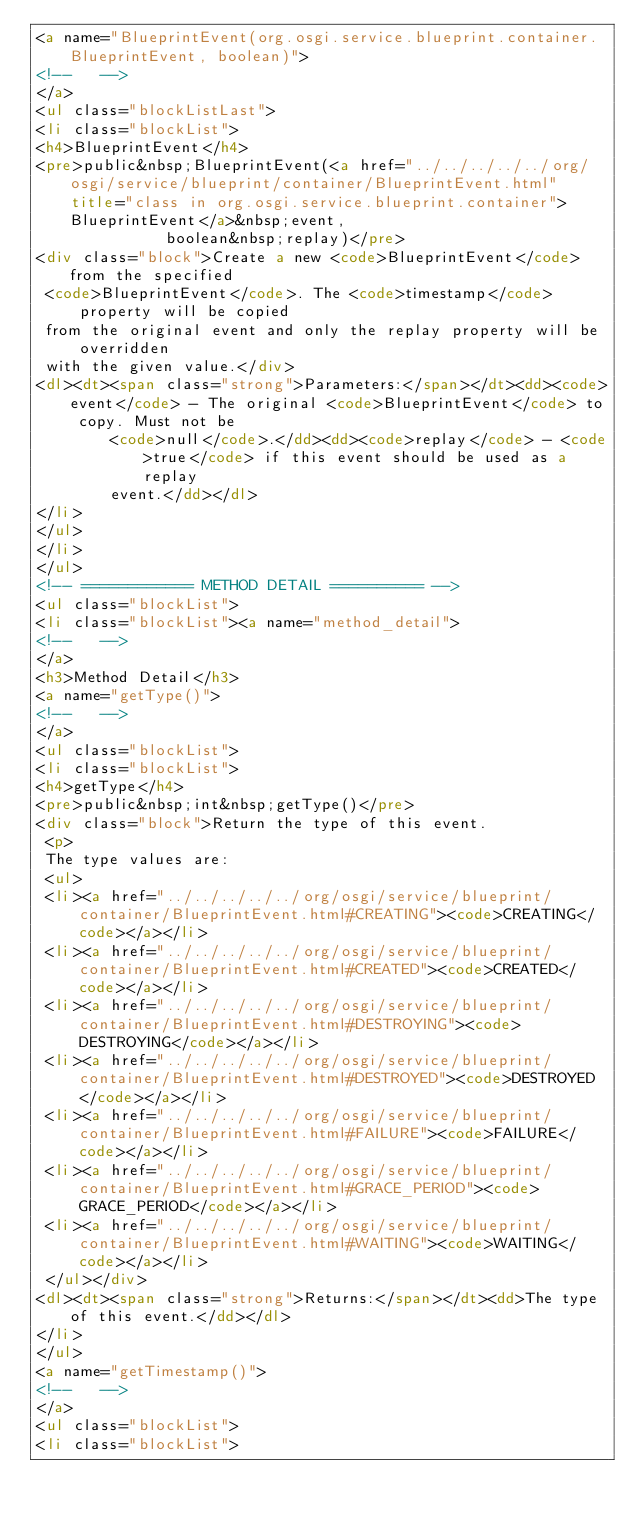<code> <loc_0><loc_0><loc_500><loc_500><_HTML_><a name="BlueprintEvent(org.osgi.service.blueprint.container.BlueprintEvent, boolean)">
<!--   -->
</a>
<ul class="blockListLast">
<li class="blockList">
<h4>BlueprintEvent</h4>
<pre>public&nbsp;BlueprintEvent(<a href="../../../../../org/osgi/service/blueprint/container/BlueprintEvent.html" title="class in org.osgi.service.blueprint.container">BlueprintEvent</a>&nbsp;event,
              boolean&nbsp;replay)</pre>
<div class="block">Create a new <code>BlueprintEvent</code> from the specified
 <code>BlueprintEvent</code>. The <code>timestamp</code> property will be copied
 from the original event and only the replay property will be overridden
 with the given value.</div>
<dl><dt><span class="strong">Parameters:</span></dt><dd><code>event</code> - The original <code>BlueprintEvent</code> to copy. Must not be
        <code>null</code>.</dd><dd><code>replay</code> - <code>true</code> if this event should be used as a replay
        event.</dd></dl>
</li>
</ul>
</li>
</ul>
<!-- ============ METHOD DETAIL ========== -->
<ul class="blockList">
<li class="blockList"><a name="method_detail">
<!--   -->
</a>
<h3>Method Detail</h3>
<a name="getType()">
<!--   -->
</a>
<ul class="blockList">
<li class="blockList">
<h4>getType</h4>
<pre>public&nbsp;int&nbsp;getType()</pre>
<div class="block">Return the type of this event.
 <p>
 The type values are:
 <ul>
 <li><a href="../../../../../org/osgi/service/blueprint/container/BlueprintEvent.html#CREATING"><code>CREATING</code></a></li>
 <li><a href="../../../../../org/osgi/service/blueprint/container/BlueprintEvent.html#CREATED"><code>CREATED</code></a></li>
 <li><a href="../../../../../org/osgi/service/blueprint/container/BlueprintEvent.html#DESTROYING"><code>DESTROYING</code></a></li>
 <li><a href="../../../../../org/osgi/service/blueprint/container/BlueprintEvent.html#DESTROYED"><code>DESTROYED</code></a></li>
 <li><a href="../../../../../org/osgi/service/blueprint/container/BlueprintEvent.html#FAILURE"><code>FAILURE</code></a></li>
 <li><a href="../../../../../org/osgi/service/blueprint/container/BlueprintEvent.html#GRACE_PERIOD"><code>GRACE_PERIOD</code></a></li>
 <li><a href="../../../../../org/osgi/service/blueprint/container/BlueprintEvent.html#WAITING"><code>WAITING</code></a></li>
 </ul></div>
<dl><dt><span class="strong">Returns:</span></dt><dd>The type of this event.</dd></dl>
</li>
</ul>
<a name="getTimestamp()">
<!--   -->
</a>
<ul class="blockList">
<li class="blockList"></code> 